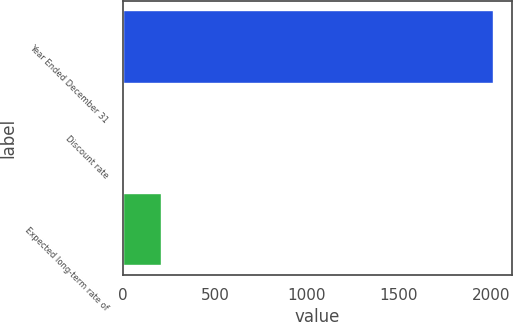<chart> <loc_0><loc_0><loc_500><loc_500><bar_chart><fcel>Year Ended December 31<fcel>Discount rate<fcel>Expected long-term rate of<nl><fcel>2014<fcel>4.75<fcel>205.68<nl></chart> 